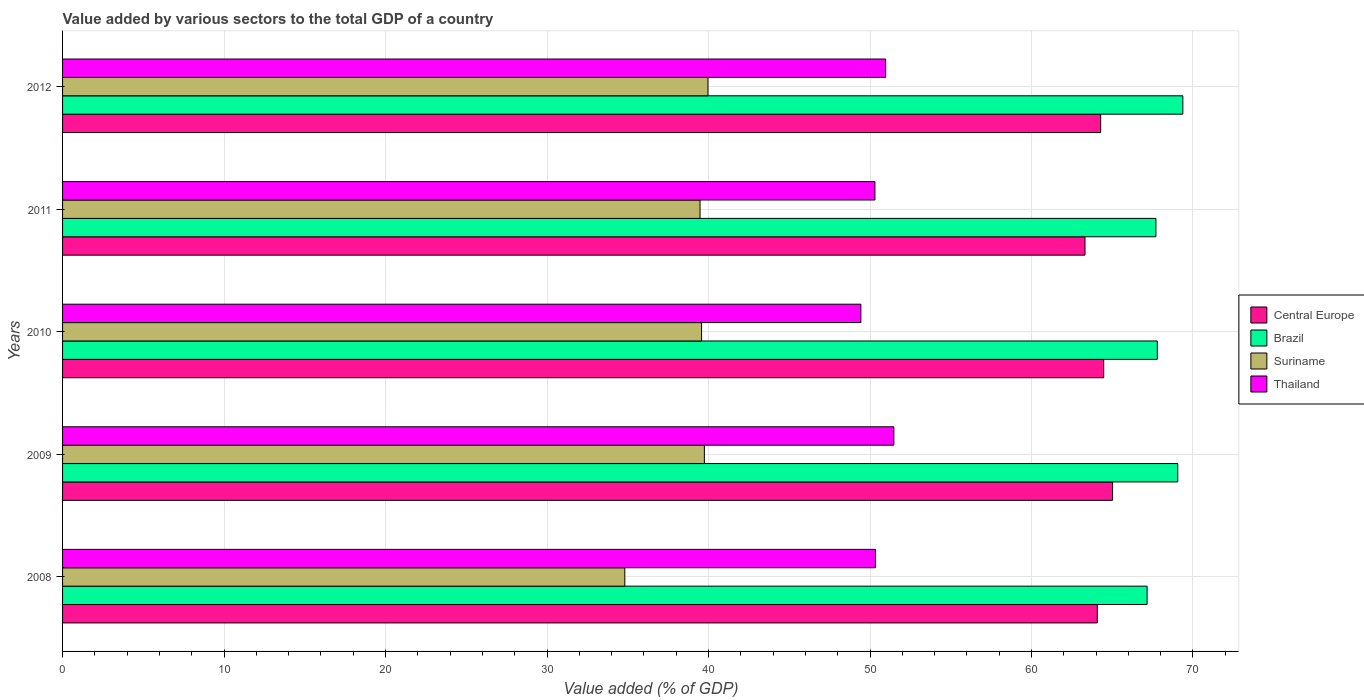How many different coloured bars are there?
Your answer should be compact. 4. How many groups of bars are there?
Your answer should be compact. 5. Are the number of bars per tick equal to the number of legend labels?
Keep it short and to the point. Yes. Are the number of bars on each tick of the Y-axis equal?
Your answer should be very brief. Yes. How many bars are there on the 4th tick from the bottom?
Your answer should be compact. 4. What is the label of the 2nd group of bars from the top?
Keep it short and to the point. 2011. In how many cases, is the number of bars for a given year not equal to the number of legend labels?
Offer a terse response. 0. What is the value added by various sectors to the total GDP in Brazil in 2011?
Provide a succinct answer. 67.71. Across all years, what is the maximum value added by various sectors to the total GDP in Thailand?
Give a very brief answer. 51.48. Across all years, what is the minimum value added by various sectors to the total GDP in Suriname?
Provide a succinct answer. 34.82. In which year was the value added by various sectors to the total GDP in Central Europe maximum?
Make the answer very short. 2009. What is the total value added by various sectors to the total GDP in Central Europe in the graph?
Your response must be concise. 321.17. What is the difference between the value added by various sectors to the total GDP in Suriname in 2009 and that in 2012?
Offer a terse response. -0.22. What is the difference between the value added by various sectors to the total GDP in Suriname in 2009 and the value added by various sectors to the total GDP in Brazil in 2011?
Offer a very short reply. -27.96. What is the average value added by various sectors to the total GDP in Suriname per year?
Your response must be concise. 38.71. In the year 2008, what is the difference between the value added by various sectors to the total GDP in Brazil and value added by various sectors to the total GDP in Suriname?
Keep it short and to the point. 32.34. In how many years, is the value added by various sectors to the total GDP in Suriname greater than 32 %?
Provide a short and direct response. 5. What is the ratio of the value added by various sectors to the total GDP in Brazil in 2008 to that in 2009?
Ensure brevity in your answer.  0.97. What is the difference between the highest and the second highest value added by various sectors to the total GDP in Brazil?
Your answer should be very brief. 0.31. What is the difference between the highest and the lowest value added by various sectors to the total GDP in Brazil?
Ensure brevity in your answer.  2.21. In how many years, is the value added by various sectors to the total GDP in Central Europe greater than the average value added by various sectors to the total GDP in Central Europe taken over all years?
Your response must be concise. 3. Is the sum of the value added by various sectors to the total GDP in Thailand in 2008 and 2011 greater than the maximum value added by various sectors to the total GDP in Suriname across all years?
Provide a short and direct response. Yes. What does the 1st bar from the bottom in 2011 represents?
Make the answer very short. Central Europe. How many bars are there?
Offer a very short reply. 20. Are all the bars in the graph horizontal?
Your answer should be compact. Yes. Does the graph contain grids?
Provide a succinct answer. Yes. Where does the legend appear in the graph?
Keep it short and to the point. Center right. How many legend labels are there?
Provide a succinct answer. 4. What is the title of the graph?
Your answer should be compact. Value added by various sectors to the total GDP of a country. Does "Israel" appear as one of the legend labels in the graph?
Offer a terse response. No. What is the label or title of the X-axis?
Provide a short and direct response. Value added (% of GDP). What is the Value added (% of GDP) in Central Europe in 2008?
Give a very brief answer. 64.08. What is the Value added (% of GDP) of Brazil in 2008?
Make the answer very short. 67.16. What is the Value added (% of GDP) of Suriname in 2008?
Keep it short and to the point. 34.82. What is the Value added (% of GDP) in Thailand in 2008?
Your answer should be compact. 50.34. What is the Value added (% of GDP) of Central Europe in 2009?
Offer a terse response. 65.02. What is the Value added (% of GDP) of Brazil in 2009?
Offer a very short reply. 69.06. What is the Value added (% of GDP) of Suriname in 2009?
Keep it short and to the point. 39.74. What is the Value added (% of GDP) of Thailand in 2009?
Keep it short and to the point. 51.48. What is the Value added (% of GDP) of Central Europe in 2010?
Ensure brevity in your answer.  64.47. What is the Value added (% of GDP) in Brazil in 2010?
Keep it short and to the point. 67.79. What is the Value added (% of GDP) of Suriname in 2010?
Ensure brevity in your answer.  39.57. What is the Value added (% of GDP) of Thailand in 2010?
Make the answer very short. 49.44. What is the Value added (% of GDP) in Central Europe in 2011?
Ensure brevity in your answer.  63.31. What is the Value added (% of GDP) of Brazil in 2011?
Your answer should be compact. 67.71. What is the Value added (% of GDP) in Suriname in 2011?
Ensure brevity in your answer.  39.48. What is the Value added (% of GDP) of Thailand in 2011?
Ensure brevity in your answer.  50.3. What is the Value added (% of GDP) of Central Europe in 2012?
Your response must be concise. 64.28. What is the Value added (% of GDP) of Brazil in 2012?
Give a very brief answer. 69.37. What is the Value added (% of GDP) in Suriname in 2012?
Make the answer very short. 39.97. What is the Value added (% of GDP) of Thailand in 2012?
Provide a succinct answer. 50.97. Across all years, what is the maximum Value added (% of GDP) of Central Europe?
Provide a short and direct response. 65.02. Across all years, what is the maximum Value added (% of GDP) of Brazil?
Offer a terse response. 69.37. Across all years, what is the maximum Value added (% of GDP) in Suriname?
Provide a succinct answer. 39.97. Across all years, what is the maximum Value added (% of GDP) in Thailand?
Your response must be concise. 51.48. Across all years, what is the minimum Value added (% of GDP) in Central Europe?
Provide a short and direct response. 63.31. Across all years, what is the minimum Value added (% of GDP) of Brazil?
Offer a very short reply. 67.16. Across all years, what is the minimum Value added (% of GDP) in Suriname?
Keep it short and to the point. 34.82. Across all years, what is the minimum Value added (% of GDP) of Thailand?
Your answer should be very brief. 49.44. What is the total Value added (% of GDP) of Central Europe in the graph?
Your answer should be compact. 321.17. What is the total Value added (% of GDP) in Brazil in the graph?
Ensure brevity in your answer.  341.09. What is the total Value added (% of GDP) in Suriname in the graph?
Provide a succinct answer. 193.57. What is the total Value added (% of GDP) in Thailand in the graph?
Give a very brief answer. 252.53. What is the difference between the Value added (% of GDP) in Central Europe in 2008 and that in 2009?
Your answer should be compact. -0.95. What is the difference between the Value added (% of GDP) in Brazil in 2008 and that in 2009?
Offer a terse response. -1.9. What is the difference between the Value added (% of GDP) of Suriname in 2008 and that in 2009?
Make the answer very short. -4.93. What is the difference between the Value added (% of GDP) in Thailand in 2008 and that in 2009?
Provide a succinct answer. -1.14. What is the difference between the Value added (% of GDP) in Central Europe in 2008 and that in 2010?
Keep it short and to the point. -0.4. What is the difference between the Value added (% of GDP) of Brazil in 2008 and that in 2010?
Give a very brief answer. -0.63. What is the difference between the Value added (% of GDP) in Suriname in 2008 and that in 2010?
Provide a short and direct response. -4.75. What is the difference between the Value added (% of GDP) in Thailand in 2008 and that in 2010?
Provide a short and direct response. 0.9. What is the difference between the Value added (% of GDP) in Central Europe in 2008 and that in 2011?
Give a very brief answer. 0.76. What is the difference between the Value added (% of GDP) of Brazil in 2008 and that in 2011?
Provide a short and direct response. -0.55. What is the difference between the Value added (% of GDP) of Suriname in 2008 and that in 2011?
Your response must be concise. -4.66. What is the difference between the Value added (% of GDP) in Thailand in 2008 and that in 2011?
Provide a succinct answer. 0.03. What is the difference between the Value added (% of GDP) in Central Europe in 2008 and that in 2012?
Give a very brief answer. -0.21. What is the difference between the Value added (% of GDP) of Brazil in 2008 and that in 2012?
Your answer should be very brief. -2.21. What is the difference between the Value added (% of GDP) in Suriname in 2008 and that in 2012?
Give a very brief answer. -5.15. What is the difference between the Value added (% of GDP) of Thailand in 2008 and that in 2012?
Provide a succinct answer. -0.63. What is the difference between the Value added (% of GDP) in Central Europe in 2009 and that in 2010?
Provide a short and direct response. 0.55. What is the difference between the Value added (% of GDP) in Brazil in 2009 and that in 2010?
Keep it short and to the point. 1.27. What is the difference between the Value added (% of GDP) of Suriname in 2009 and that in 2010?
Offer a terse response. 0.17. What is the difference between the Value added (% of GDP) of Thailand in 2009 and that in 2010?
Your answer should be compact. 2.04. What is the difference between the Value added (% of GDP) of Central Europe in 2009 and that in 2011?
Give a very brief answer. 1.71. What is the difference between the Value added (% of GDP) of Brazil in 2009 and that in 2011?
Keep it short and to the point. 1.35. What is the difference between the Value added (% of GDP) of Suriname in 2009 and that in 2011?
Offer a very short reply. 0.27. What is the difference between the Value added (% of GDP) in Thailand in 2009 and that in 2011?
Ensure brevity in your answer.  1.17. What is the difference between the Value added (% of GDP) of Central Europe in 2009 and that in 2012?
Offer a terse response. 0.74. What is the difference between the Value added (% of GDP) of Brazil in 2009 and that in 2012?
Give a very brief answer. -0.31. What is the difference between the Value added (% of GDP) in Suriname in 2009 and that in 2012?
Your answer should be very brief. -0.22. What is the difference between the Value added (% of GDP) in Thailand in 2009 and that in 2012?
Ensure brevity in your answer.  0.51. What is the difference between the Value added (% of GDP) in Central Europe in 2010 and that in 2011?
Your response must be concise. 1.16. What is the difference between the Value added (% of GDP) in Brazil in 2010 and that in 2011?
Your answer should be compact. 0.08. What is the difference between the Value added (% of GDP) of Suriname in 2010 and that in 2011?
Provide a succinct answer. 0.09. What is the difference between the Value added (% of GDP) of Thailand in 2010 and that in 2011?
Your response must be concise. -0.87. What is the difference between the Value added (% of GDP) in Central Europe in 2010 and that in 2012?
Your answer should be very brief. 0.19. What is the difference between the Value added (% of GDP) of Brazil in 2010 and that in 2012?
Keep it short and to the point. -1.58. What is the difference between the Value added (% of GDP) of Suriname in 2010 and that in 2012?
Ensure brevity in your answer.  -0.4. What is the difference between the Value added (% of GDP) of Thailand in 2010 and that in 2012?
Make the answer very short. -1.53. What is the difference between the Value added (% of GDP) in Central Europe in 2011 and that in 2012?
Offer a terse response. -0.97. What is the difference between the Value added (% of GDP) of Brazil in 2011 and that in 2012?
Your answer should be compact. -1.67. What is the difference between the Value added (% of GDP) of Suriname in 2011 and that in 2012?
Make the answer very short. -0.49. What is the difference between the Value added (% of GDP) of Thailand in 2011 and that in 2012?
Give a very brief answer. -0.67. What is the difference between the Value added (% of GDP) in Central Europe in 2008 and the Value added (% of GDP) in Brazil in 2009?
Your response must be concise. -4.98. What is the difference between the Value added (% of GDP) of Central Europe in 2008 and the Value added (% of GDP) of Suriname in 2009?
Make the answer very short. 24.33. What is the difference between the Value added (% of GDP) of Central Europe in 2008 and the Value added (% of GDP) of Thailand in 2009?
Your response must be concise. 12.6. What is the difference between the Value added (% of GDP) in Brazil in 2008 and the Value added (% of GDP) in Suriname in 2009?
Offer a very short reply. 27.41. What is the difference between the Value added (% of GDP) of Brazil in 2008 and the Value added (% of GDP) of Thailand in 2009?
Make the answer very short. 15.68. What is the difference between the Value added (% of GDP) of Suriname in 2008 and the Value added (% of GDP) of Thailand in 2009?
Your response must be concise. -16.66. What is the difference between the Value added (% of GDP) of Central Europe in 2008 and the Value added (% of GDP) of Brazil in 2010?
Offer a very short reply. -3.72. What is the difference between the Value added (% of GDP) in Central Europe in 2008 and the Value added (% of GDP) in Suriname in 2010?
Keep it short and to the point. 24.51. What is the difference between the Value added (% of GDP) of Central Europe in 2008 and the Value added (% of GDP) of Thailand in 2010?
Give a very brief answer. 14.64. What is the difference between the Value added (% of GDP) in Brazil in 2008 and the Value added (% of GDP) in Suriname in 2010?
Offer a very short reply. 27.59. What is the difference between the Value added (% of GDP) in Brazil in 2008 and the Value added (% of GDP) in Thailand in 2010?
Ensure brevity in your answer.  17.72. What is the difference between the Value added (% of GDP) of Suriname in 2008 and the Value added (% of GDP) of Thailand in 2010?
Keep it short and to the point. -14.62. What is the difference between the Value added (% of GDP) of Central Europe in 2008 and the Value added (% of GDP) of Brazil in 2011?
Give a very brief answer. -3.63. What is the difference between the Value added (% of GDP) in Central Europe in 2008 and the Value added (% of GDP) in Suriname in 2011?
Your response must be concise. 24.6. What is the difference between the Value added (% of GDP) of Central Europe in 2008 and the Value added (% of GDP) of Thailand in 2011?
Make the answer very short. 13.77. What is the difference between the Value added (% of GDP) in Brazil in 2008 and the Value added (% of GDP) in Suriname in 2011?
Your answer should be very brief. 27.68. What is the difference between the Value added (% of GDP) of Brazil in 2008 and the Value added (% of GDP) of Thailand in 2011?
Offer a terse response. 16.85. What is the difference between the Value added (% of GDP) in Suriname in 2008 and the Value added (% of GDP) in Thailand in 2011?
Your answer should be compact. -15.49. What is the difference between the Value added (% of GDP) of Central Europe in 2008 and the Value added (% of GDP) of Brazil in 2012?
Offer a terse response. -5.3. What is the difference between the Value added (% of GDP) of Central Europe in 2008 and the Value added (% of GDP) of Suriname in 2012?
Offer a terse response. 24.11. What is the difference between the Value added (% of GDP) of Central Europe in 2008 and the Value added (% of GDP) of Thailand in 2012?
Ensure brevity in your answer.  13.11. What is the difference between the Value added (% of GDP) of Brazil in 2008 and the Value added (% of GDP) of Suriname in 2012?
Ensure brevity in your answer.  27.19. What is the difference between the Value added (% of GDP) of Brazil in 2008 and the Value added (% of GDP) of Thailand in 2012?
Give a very brief answer. 16.19. What is the difference between the Value added (% of GDP) in Suriname in 2008 and the Value added (% of GDP) in Thailand in 2012?
Your answer should be compact. -16.15. What is the difference between the Value added (% of GDP) of Central Europe in 2009 and the Value added (% of GDP) of Brazil in 2010?
Keep it short and to the point. -2.77. What is the difference between the Value added (% of GDP) of Central Europe in 2009 and the Value added (% of GDP) of Suriname in 2010?
Offer a terse response. 25.45. What is the difference between the Value added (% of GDP) of Central Europe in 2009 and the Value added (% of GDP) of Thailand in 2010?
Make the answer very short. 15.59. What is the difference between the Value added (% of GDP) of Brazil in 2009 and the Value added (% of GDP) of Suriname in 2010?
Provide a short and direct response. 29.49. What is the difference between the Value added (% of GDP) in Brazil in 2009 and the Value added (% of GDP) in Thailand in 2010?
Offer a terse response. 19.62. What is the difference between the Value added (% of GDP) of Suriname in 2009 and the Value added (% of GDP) of Thailand in 2010?
Offer a terse response. -9.69. What is the difference between the Value added (% of GDP) in Central Europe in 2009 and the Value added (% of GDP) in Brazil in 2011?
Keep it short and to the point. -2.69. What is the difference between the Value added (% of GDP) of Central Europe in 2009 and the Value added (% of GDP) of Suriname in 2011?
Keep it short and to the point. 25.55. What is the difference between the Value added (% of GDP) in Central Europe in 2009 and the Value added (% of GDP) in Thailand in 2011?
Provide a succinct answer. 14.72. What is the difference between the Value added (% of GDP) in Brazil in 2009 and the Value added (% of GDP) in Suriname in 2011?
Your answer should be compact. 29.58. What is the difference between the Value added (% of GDP) of Brazil in 2009 and the Value added (% of GDP) of Thailand in 2011?
Your answer should be compact. 18.75. What is the difference between the Value added (% of GDP) in Suriname in 2009 and the Value added (% of GDP) in Thailand in 2011?
Offer a terse response. -10.56. What is the difference between the Value added (% of GDP) of Central Europe in 2009 and the Value added (% of GDP) of Brazil in 2012?
Provide a succinct answer. -4.35. What is the difference between the Value added (% of GDP) in Central Europe in 2009 and the Value added (% of GDP) in Suriname in 2012?
Offer a terse response. 25.05. What is the difference between the Value added (% of GDP) of Central Europe in 2009 and the Value added (% of GDP) of Thailand in 2012?
Provide a succinct answer. 14.05. What is the difference between the Value added (% of GDP) in Brazil in 2009 and the Value added (% of GDP) in Suriname in 2012?
Provide a succinct answer. 29.09. What is the difference between the Value added (% of GDP) in Brazil in 2009 and the Value added (% of GDP) in Thailand in 2012?
Offer a very short reply. 18.09. What is the difference between the Value added (% of GDP) in Suriname in 2009 and the Value added (% of GDP) in Thailand in 2012?
Your response must be concise. -11.23. What is the difference between the Value added (% of GDP) of Central Europe in 2010 and the Value added (% of GDP) of Brazil in 2011?
Your answer should be very brief. -3.23. What is the difference between the Value added (% of GDP) of Central Europe in 2010 and the Value added (% of GDP) of Suriname in 2011?
Provide a succinct answer. 25. What is the difference between the Value added (% of GDP) in Central Europe in 2010 and the Value added (% of GDP) in Thailand in 2011?
Keep it short and to the point. 14.17. What is the difference between the Value added (% of GDP) in Brazil in 2010 and the Value added (% of GDP) in Suriname in 2011?
Give a very brief answer. 28.32. What is the difference between the Value added (% of GDP) in Brazil in 2010 and the Value added (% of GDP) in Thailand in 2011?
Keep it short and to the point. 17.49. What is the difference between the Value added (% of GDP) in Suriname in 2010 and the Value added (% of GDP) in Thailand in 2011?
Offer a very short reply. -10.73. What is the difference between the Value added (% of GDP) in Central Europe in 2010 and the Value added (% of GDP) in Brazil in 2012?
Offer a terse response. -4.9. What is the difference between the Value added (% of GDP) of Central Europe in 2010 and the Value added (% of GDP) of Suriname in 2012?
Provide a short and direct response. 24.51. What is the difference between the Value added (% of GDP) in Central Europe in 2010 and the Value added (% of GDP) in Thailand in 2012?
Offer a very short reply. 13.5. What is the difference between the Value added (% of GDP) of Brazil in 2010 and the Value added (% of GDP) of Suriname in 2012?
Provide a short and direct response. 27.83. What is the difference between the Value added (% of GDP) in Brazil in 2010 and the Value added (% of GDP) in Thailand in 2012?
Your response must be concise. 16.82. What is the difference between the Value added (% of GDP) of Suriname in 2010 and the Value added (% of GDP) of Thailand in 2012?
Provide a succinct answer. -11.4. What is the difference between the Value added (% of GDP) of Central Europe in 2011 and the Value added (% of GDP) of Brazil in 2012?
Keep it short and to the point. -6.06. What is the difference between the Value added (% of GDP) in Central Europe in 2011 and the Value added (% of GDP) in Suriname in 2012?
Ensure brevity in your answer.  23.35. What is the difference between the Value added (% of GDP) in Central Europe in 2011 and the Value added (% of GDP) in Thailand in 2012?
Your answer should be compact. 12.34. What is the difference between the Value added (% of GDP) in Brazil in 2011 and the Value added (% of GDP) in Suriname in 2012?
Keep it short and to the point. 27.74. What is the difference between the Value added (% of GDP) in Brazil in 2011 and the Value added (% of GDP) in Thailand in 2012?
Provide a short and direct response. 16.74. What is the difference between the Value added (% of GDP) in Suriname in 2011 and the Value added (% of GDP) in Thailand in 2012?
Your answer should be compact. -11.49. What is the average Value added (% of GDP) of Central Europe per year?
Make the answer very short. 64.23. What is the average Value added (% of GDP) in Brazil per year?
Make the answer very short. 68.22. What is the average Value added (% of GDP) in Suriname per year?
Provide a short and direct response. 38.71. What is the average Value added (% of GDP) in Thailand per year?
Your response must be concise. 50.51. In the year 2008, what is the difference between the Value added (% of GDP) of Central Europe and Value added (% of GDP) of Brazil?
Provide a short and direct response. -3.08. In the year 2008, what is the difference between the Value added (% of GDP) in Central Europe and Value added (% of GDP) in Suriname?
Offer a very short reply. 29.26. In the year 2008, what is the difference between the Value added (% of GDP) of Central Europe and Value added (% of GDP) of Thailand?
Give a very brief answer. 13.74. In the year 2008, what is the difference between the Value added (% of GDP) in Brazil and Value added (% of GDP) in Suriname?
Provide a succinct answer. 32.34. In the year 2008, what is the difference between the Value added (% of GDP) of Brazil and Value added (% of GDP) of Thailand?
Provide a succinct answer. 16.82. In the year 2008, what is the difference between the Value added (% of GDP) in Suriname and Value added (% of GDP) in Thailand?
Provide a succinct answer. -15.52. In the year 2009, what is the difference between the Value added (% of GDP) of Central Europe and Value added (% of GDP) of Brazil?
Give a very brief answer. -4.04. In the year 2009, what is the difference between the Value added (% of GDP) in Central Europe and Value added (% of GDP) in Suriname?
Provide a succinct answer. 25.28. In the year 2009, what is the difference between the Value added (% of GDP) of Central Europe and Value added (% of GDP) of Thailand?
Provide a short and direct response. 13.54. In the year 2009, what is the difference between the Value added (% of GDP) of Brazil and Value added (% of GDP) of Suriname?
Offer a very short reply. 29.31. In the year 2009, what is the difference between the Value added (% of GDP) of Brazil and Value added (% of GDP) of Thailand?
Your response must be concise. 17.58. In the year 2009, what is the difference between the Value added (% of GDP) in Suriname and Value added (% of GDP) in Thailand?
Keep it short and to the point. -11.73. In the year 2010, what is the difference between the Value added (% of GDP) of Central Europe and Value added (% of GDP) of Brazil?
Provide a short and direct response. -3.32. In the year 2010, what is the difference between the Value added (% of GDP) in Central Europe and Value added (% of GDP) in Suriname?
Give a very brief answer. 24.9. In the year 2010, what is the difference between the Value added (% of GDP) of Central Europe and Value added (% of GDP) of Thailand?
Ensure brevity in your answer.  15.04. In the year 2010, what is the difference between the Value added (% of GDP) of Brazil and Value added (% of GDP) of Suriname?
Your answer should be compact. 28.22. In the year 2010, what is the difference between the Value added (% of GDP) in Brazil and Value added (% of GDP) in Thailand?
Offer a terse response. 18.36. In the year 2010, what is the difference between the Value added (% of GDP) in Suriname and Value added (% of GDP) in Thailand?
Give a very brief answer. -9.87. In the year 2011, what is the difference between the Value added (% of GDP) of Central Europe and Value added (% of GDP) of Brazil?
Keep it short and to the point. -4.39. In the year 2011, what is the difference between the Value added (% of GDP) in Central Europe and Value added (% of GDP) in Suriname?
Ensure brevity in your answer.  23.84. In the year 2011, what is the difference between the Value added (% of GDP) of Central Europe and Value added (% of GDP) of Thailand?
Ensure brevity in your answer.  13.01. In the year 2011, what is the difference between the Value added (% of GDP) of Brazil and Value added (% of GDP) of Suriname?
Provide a short and direct response. 28.23. In the year 2011, what is the difference between the Value added (% of GDP) in Brazil and Value added (% of GDP) in Thailand?
Keep it short and to the point. 17.4. In the year 2011, what is the difference between the Value added (% of GDP) in Suriname and Value added (% of GDP) in Thailand?
Provide a succinct answer. -10.83. In the year 2012, what is the difference between the Value added (% of GDP) of Central Europe and Value added (% of GDP) of Brazil?
Offer a terse response. -5.09. In the year 2012, what is the difference between the Value added (% of GDP) of Central Europe and Value added (% of GDP) of Suriname?
Your answer should be compact. 24.32. In the year 2012, what is the difference between the Value added (% of GDP) in Central Europe and Value added (% of GDP) in Thailand?
Your answer should be very brief. 13.31. In the year 2012, what is the difference between the Value added (% of GDP) in Brazil and Value added (% of GDP) in Suriname?
Your answer should be very brief. 29.41. In the year 2012, what is the difference between the Value added (% of GDP) of Brazil and Value added (% of GDP) of Thailand?
Your response must be concise. 18.4. In the year 2012, what is the difference between the Value added (% of GDP) of Suriname and Value added (% of GDP) of Thailand?
Provide a short and direct response. -11. What is the ratio of the Value added (% of GDP) of Central Europe in 2008 to that in 2009?
Give a very brief answer. 0.99. What is the ratio of the Value added (% of GDP) in Brazil in 2008 to that in 2009?
Make the answer very short. 0.97. What is the ratio of the Value added (% of GDP) in Suriname in 2008 to that in 2009?
Ensure brevity in your answer.  0.88. What is the ratio of the Value added (% of GDP) of Thailand in 2008 to that in 2009?
Ensure brevity in your answer.  0.98. What is the ratio of the Value added (% of GDP) in Brazil in 2008 to that in 2010?
Make the answer very short. 0.99. What is the ratio of the Value added (% of GDP) in Suriname in 2008 to that in 2010?
Offer a terse response. 0.88. What is the ratio of the Value added (% of GDP) in Thailand in 2008 to that in 2010?
Offer a terse response. 1.02. What is the ratio of the Value added (% of GDP) of Suriname in 2008 to that in 2011?
Give a very brief answer. 0.88. What is the ratio of the Value added (% of GDP) in Central Europe in 2008 to that in 2012?
Give a very brief answer. 1. What is the ratio of the Value added (% of GDP) of Brazil in 2008 to that in 2012?
Give a very brief answer. 0.97. What is the ratio of the Value added (% of GDP) of Suriname in 2008 to that in 2012?
Keep it short and to the point. 0.87. What is the ratio of the Value added (% of GDP) of Thailand in 2008 to that in 2012?
Provide a short and direct response. 0.99. What is the ratio of the Value added (% of GDP) of Central Europe in 2009 to that in 2010?
Offer a terse response. 1.01. What is the ratio of the Value added (% of GDP) in Brazil in 2009 to that in 2010?
Offer a very short reply. 1.02. What is the ratio of the Value added (% of GDP) in Thailand in 2009 to that in 2010?
Your answer should be compact. 1.04. What is the ratio of the Value added (% of GDP) of Central Europe in 2009 to that in 2011?
Offer a terse response. 1.03. What is the ratio of the Value added (% of GDP) of Brazil in 2009 to that in 2011?
Your response must be concise. 1.02. What is the ratio of the Value added (% of GDP) of Suriname in 2009 to that in 2011?
Your answer should be compact. 1.01. What is the ratio of the Value added (% of GDP) in Thailand in 2009 to that in 2011?
Offer a very short reply. 1.02. What is the ratio of the Value added (% of GDP) in Central Europe in 2009 to that in 2012?
Keep it short and to the point. 1.01. What is the ratio of the Value added (% of GDP) in Brazil in 2009 to that in 2012?
Your response must be concise. 1. What is the ratio of the Value added (% of GDP) of Central Europe in 2010 to that in 2011?
Your response must be concise. 1.02. What is the ratio of the Value added (% of GDP) of Brazil in 2010 to that in 2011?
Offer a terse response. 1. What is the ratio of the Value added (% of GDP) in Suriname in 2010 to that in 2011?
Keep it short and to the point. 1. What is the ratio of the Value added (% of GDP) of Thailand in 2010 to that in 2011?
Keep it short and to the point. 0.98. What is the ratio of the Value added (% of GDP) in Central Europe in 2010 to that in 2012?
Keep it short and to the point. 1. What is the ratio of the Value added (% of GDP) in Brazil in 2010 to that in 2012?
Give a very brief answer. 0.98. What is the ratio of the Value added (% of GDP) in Thailand in 2010 to that in 2012?
Provide a succinct answer. 0.97. What is the ratio of the Value added (% of GDP) of Central Europe in 2011 to that in 2012?
Offer a very short reply. 0.98. What is the ratio of the Value added (% of GDP) of Brazil in 2011 to that in 2012?
Your response must be concise. 0.98. What is the ratio of the Value added (% of GDP) of Suriname in 2011 to that in 2012?
Give a very brief answer. 0.99. What is the ratio of the Value added (% of GDP) in Thailand in 2011 to that in 2012?
Make the answer very short. 0.99. What is the difference between the highest and the second highest Value added (% of GDP) in Central Europe?
Offer a very short reply. 0.55. What is the difference between the highest and the second highest Value added (% of GDP) of Brazil?
Make the answer very short. 0.31. What is the difference between the highest and the second highest Value added (% of GDP) in Suriname?
Provide a short and direct response. 0.22. What is the difference between the highest and the second highest Value added (% of GDP) of Thailand?
Give a very brief answer. 0.51. What is the difference between the highest and the lowest Value added (% of GDP) in Central Europe?
Give a very brief answer. 1.71. What is the difference between the highest and the lowest Value added (% of GDP) in Brazil?
Ensure brevity in your answer.  2.21. What is the difference between the highest and the lowest Value added (% of GDP) in Suriname?
Provide a succinct answer. 5.15. What is the difference between the highest and the lowest Value added (% of GDP) in Thailand?
Provide a succinct answer. 2.04. 